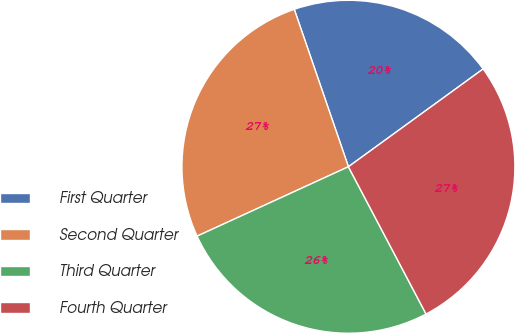Convert chart. <chart><loc_0><loc_0><loc_500><loc_500><pie_chart><fcel>First Quarter<fcel>Second Quarter<fcel>Third Quarter<fcel>Fourth Quarter<nl><fcel>20.28%<fcel>26.57%<fcel>25.88%<fcel>27.27%<nl></chart> 